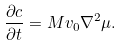<formula> <loc_0><loc_0><loc_500><loc_500>\frac { \partial c } { \partial t } = M v _ { 0 } \nabla ^ { 2 } \mu .</formula> 